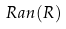Convert formula to latex. <formula><loc_0><loc_0><loc_500><loc_500>R a n ( R )</formula> 